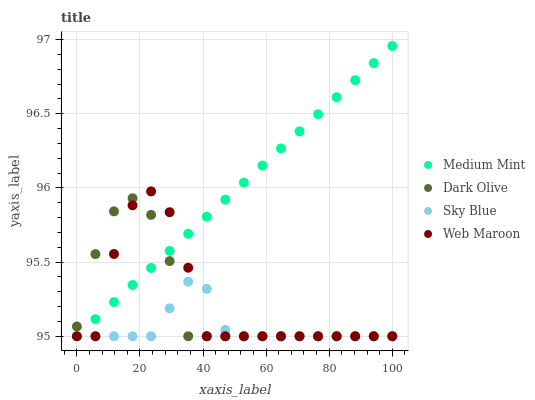Does Sky Blue have the minimum area under the curve?
Answer yes or no. Yes. Does Medium Mint have the maximum area under the curve?
Answer yes or no. Yes. Does Dark Olive have the minimum area under the curve?
Answer yes or no. No. Does Dark Olive have the maximum area under the curve?
Answer yes or no. No. Is Medium Mint the smoothest?
Answer yes or no. Yes. Is Web Maroon the roughest?
Answer yes or no. Yes. Is Sky Blue the smoothest?
Answer yes or no. No. Is Sky Blue the roughest?
Answer yes or no. No. Does Medium Mint have the lowest value?
Answer yes or no. Yes. Does Medium Mint have the highest value?
Answer yes or no. Yes. Does Dark Olive have the highest value?
Answer yes or no. No. Does Web Maroon intersect Sky Blue?
Answer yes or no. Yes. Is Web Maroon less than Sky Blue?
Answer yes or no. No. Is Web Maroon greater than Sky Blue?
Answer yes or no. No. 